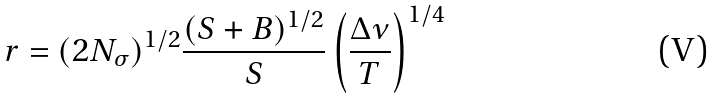Convert formula to latex. <formula><loc_0><loc_0><loc_500><loc_500>r = ( 2 N _ { \sigma } ) ^ { 1 / 2 } \frac { ( S + B ) ^ { 1 / 2 } } { S } \left ( \frac { \Delta \nu } { T } \right ) ^ { 1 / 4 }</formula> 